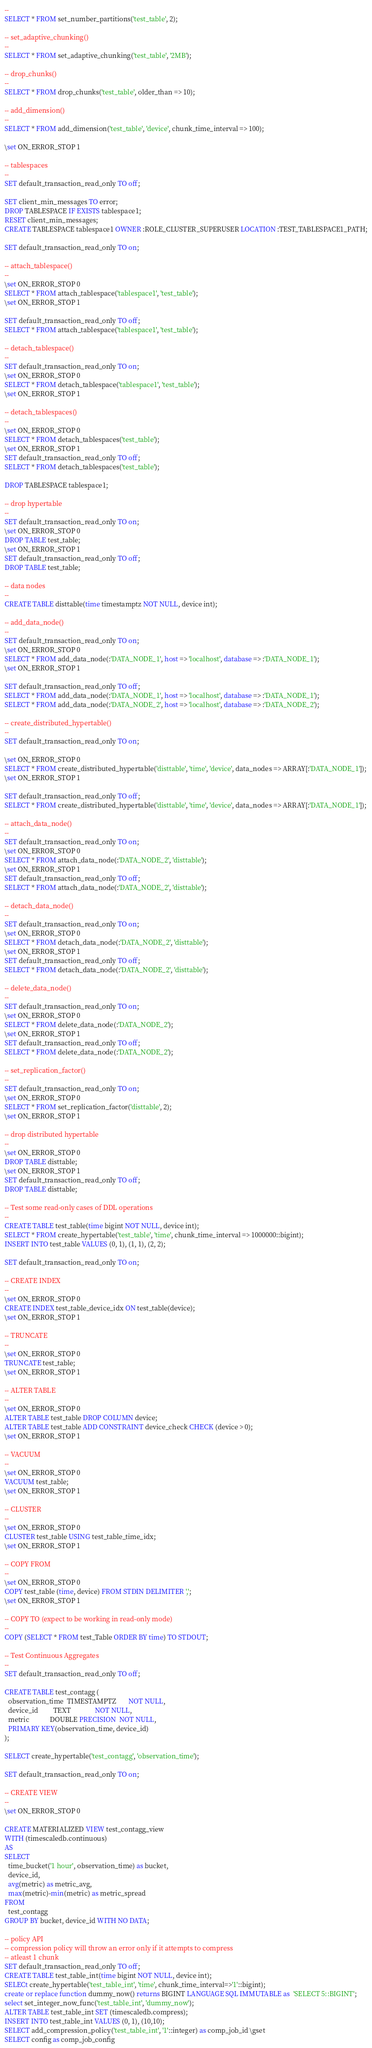Convert code to text. <code><loc_0><loc_0><loc_500><loc_500><_SQL_>--
SELECT * FROM set_number_partitions('test_table', 2);

-- set_adaptive_chunking()
--
SELECT * FROM set_adaptive_chunking('test_table', '2MB');

-- drop_chunks()
--
SELECT * FROM drop_chunks('test_table', older_than => 10);

-- add_dimension()
--
SELECT * FROM add_dimension('test_table', 'device', chunk_time_interval => 100);

\set ON_ERROR_STOP 1

-- tablespaces
--
SET default_transaction_read_only TO off;

SET client_min_messages TO error;
DROP TABLESPACE IF EXISTS tablespace1;
RESET client_min_messages;
CREATE TABLESPACE tablespace1 OWNER :ROLE_CLUSTER_SUPERUSER LOCATION :TEST_TABLESPACE1_PATH;

SET default_transaction_read_only TO on;

-- attach_tablespace()
--
\set ON_ERROR_STOP 0
SELECT * FROM attach_tablespace('tablespace1', 'test_table');
\set ON_ERROR_STOP 1

SET default_transaction_read_only TO off;
SELECT * FROM attach_tablespace('tablespace1', 'test_table');

-- detach_tablespace()
--
SET default_transaction_read_only TO on;
\set ON_ERROR_STOP 0
SELECT * FROM detach_tablespace('tablespace1', 'test_table');
\set ON_ERROR_STOP 1

-- detach_tablespaces()
--
\set ON_ERROR_STOP 0
SELECT * FROM detach_tablespaces('test_table');
\set ON_ERROR_STOP 1
SET default_transaction_read_only TO off;
SELECT * FROM detach_tablespaces('test_table');

DROP TABLESPACE tablespace1;

-- drop hypertable
--
SET default_transaction_read_only TO on;
\set ON_ERROR_STOP 0
DROP TABLE test_table;
\set ON_ERROR_STOP 1
SET default_transaction_read_only TO off;
DROP TABLE test_table;

-- data nodes
--
CREATE TABLE disttable(time timestamptz NOT NULL, device int);

-- add_data_node()
--
SET default_transaction_read_only TO on;
\set ON_ERROR_STOP 0
SELECT * FROM add_data_node(:'DATA_NODE_1', host => 'localhost', database => :'DATA_NODE_1');
\set ON_ERROR_STOP 1

SET default_transaction_read_only TO off;
SELECT * FROM add_data_node(:'DATA_NODE_1', host => 'localhost', database => :'DATA_NODE_1');
SELECT * FROM add_data_node(:'DATA_NODE_2', host => 'localhost', database => :'DATA_NODE_2');

-- create_distributed_hypertable()
--
SET default_transaction_read_only TO on;

\set ON_ERROR_STOP 0
SELECT * FROM create_distributed_hypertable('disttable', 'time', 'device', data_nodes => ARRAY[:'DATA_NODE_1']);
\set ON_ERROR_STOP 1

SET default_transaction_read_only TO off;
SELECT * FROM create_distributed_hypertable('disttable', 'time', 'device', data_nodes => ARRAY[:'DATA_NODE_1']);

-- attach_data_node()
--
SET default_transaction_read_only TO on;
\set ON_ERROR_STOP 0
SELECT * FROM attach_data_node(:'DATA_NODE_2', 'disttable');
\set ON_ERROR_STOP 1
SET default_transaction_read_only TO off;
SELECT * FROM attach_data_node(:'DATA_NODE_2', 'disttable');

-- detach_data_node()
--
SET default_transaction_read_only TO on;
\set ON_ERROR_STOP 0
SELECT * FROM detach_data_node(:'DATA_NODE_2', 'disttable');
\set ON_ERROR_STOP 1
SET default_transaction_read_only TO off;
SELECT * FROM detach_data_node(:'DATA_NODE_2', 'disttable');

-- delete_data_node()
--
SET default_transaction_read_only TO on;
\set ON_ERROR_STOP 0
SELECT * FROM delete_data_node(:'DATA_NODE_2');
\set ON_ERROR_STOP 1
SET default_transaction_read_only TO off;
SELECT * FROM delete_data_node(:'DATA_NODE_2');

-- set_replication_factor()
--
SET default_transaction_read_only TO on;
\set ON_ERROR_STOP 0
SELECT * FROM set_replication_factor('disttable', 2);
\set ON_ERROR_STOP 1

-- drop distributed hypertable
--
\set ON_ERROR_STOP 0
DROP TABLE disttable;
\set ON_ERROR_STOP 1
SET default_transaction_read_only TO off;
DROP TABLE disttable;

-- Test some read-only cases of DDL operations
-- 
CREATE TABLE test_table(time bigint NOT NULL, device int);
SELECT * FROM create_hypertable('test_table', 'time', chunk_time_interval => 1000000::bigint);
INSERT INTO test_table VALUES (0, 1), (1, 1), (2, 2);

SET default_transaction_read_only TO on;

-- CREATE INDEX
--
\set ON_ERROR_STOP 0
CREATE INDEX test_table_device_idx ON test_table(device);
\set ON_ERROR_STOP 1

-- TRUNCATE
--
\set ON_ERROR_STOP 0
TRUNCATE test_table;
\set ON_ERROR_STOP 1

-- ALTER TABLE
--
\set ON_ERROR_STOP 0
ALTER TABLE test_table DROP COLUMN device;
ALTER TABLE test_table ADD CONSTRAINT device_check CHECK (device > 0);
\set ON_ERROR_STOP 1

-- VACUUM
--
\set ON_ERROR_STOP 0
VACUUM test_table;
\set ON_ERROR_STOP 1

-- CLUSTER
--
\set ON_ERROR_STOP 0
CLUSTER test_table USING test_table_time_idx;
\set ON_ERROR_STOP 1

-- COPY FROM
--
\set ON_ERROR_STOP 0
COPY test_table (time, device) FROM STDIN DELIMITER ',';
\set ON_ERROR_STOP 1

-- COPY TO (expect to be working in read-only mode)
--
COPY (SELECT * FROM test_Table ORDER BY time) TO STDOUT;

-- Test Continuous Aggregates
-- 
SET default_transaction_read_only TO off;

CREATE TABLE test_contagg (
  observation_time  TIMESTAMPTZ       NOT NULL,
  device_id         TEXT              NOT NULL,
  metric            DOUBLE PRECISION  NOT NULL,
  PRIMARY KEY(observation_time, device_id)
);

SELECT create_hypertable('test_contagg', 'observation_time');

SET default_transaction_read_only TO on;

-- CREATE VIEW
--
\set ON_ERROR_STOP 0

CREATE MATERIALIZED VIEW test_contagg_view
WITH (timescaledb.continuous)
AS
SELECT
  time_bucket('1 hour', observation_time) as bucket,
  device_id,
  avg(metric) as metric_avg,
  max(metric)-min(metric) as metric_spread
FROM
  test_contagg
GROUP BY bucket, device_id WITH NO DATA;

-- policy API
-- compression policy will throw an error only if it attempts to compress
-- atleast 1 chunk
SET default_transaction_read_only TO off;
CREATE TABLE test_table_int(time bigint NOT NULL, device int);
SELECt create_hypertable('test_table_int', 'time', chunk_time_interval=>'1'::bigint);
create or replace function dummy_now() returns BIGINT LANGUAGE SQL IMMUTABLE as  'SELECT 5::BIGINT';
select set_integer_now_func('test_table_int', 'dummy_now');
ALTER TABLE test_table_int SET (timescaledb.compress);
INSERT INTO test_table_int VALUES (0, 1), (10,10);
SELECT add_compression_policy('test_table_int', '1'::integer) as comp_job_id \gset
SELECT config as comp_job_config </code> 